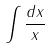Convert formula to latex. <formula><loc_0><loc_0><loc_500><loc_500>\int \frac { d x } { x }</formula> 